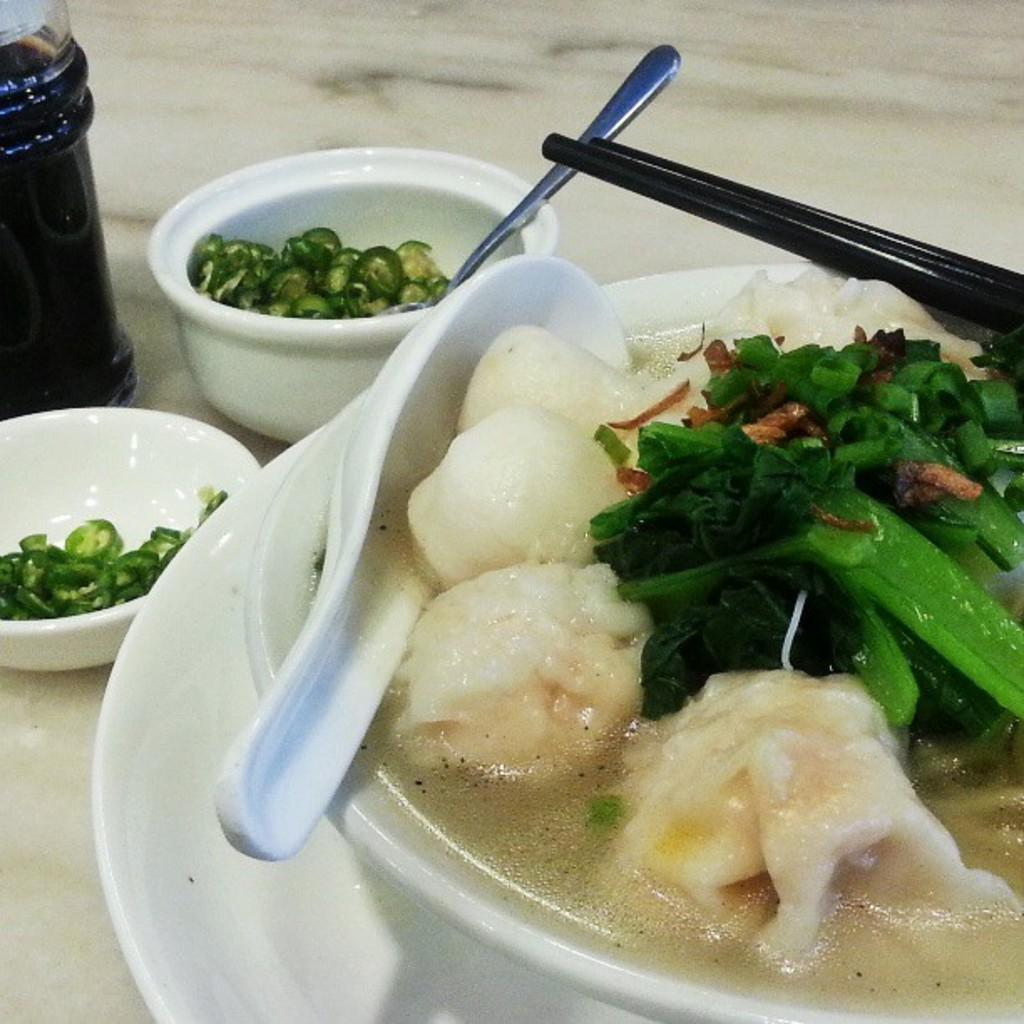What is in the bowl that is visible in the image? There is food in a bowl in the image. What utensil is present in the image? A spoon is present in the image. What is located at the bottom of the image? There is a plate at the bottom of the image. How many bowls are on the left side of the image? There are two bowls on the left side of the image. What object is on the floor in the image? There is a jar on the floor in the image. What is the credit score of the person who prepared the food in the image? There is no information about the person who prepared the food in the image, nor is there any mention of credit scores. 